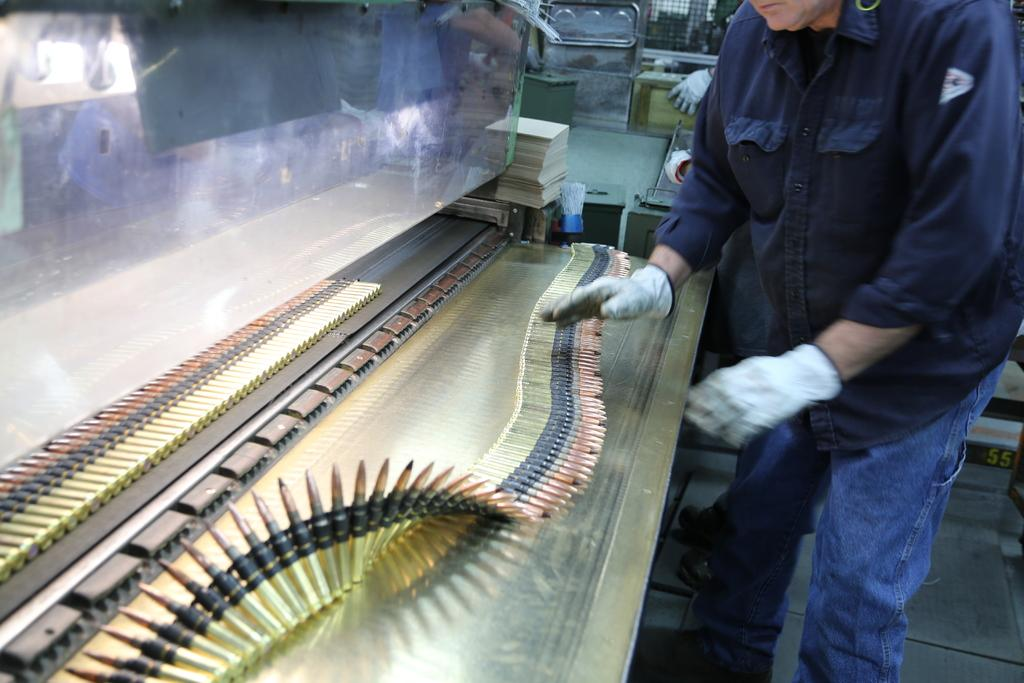What is the main subject of the image? There is a person standing in the image. What can be seen on the table in the image? There is a sheet of bullets on a table in the image. What type of honey is being used to sweeten the bean in the image? There is no honey or bean present in the image; it only features a person standing and a sheet of bullets on a table. 